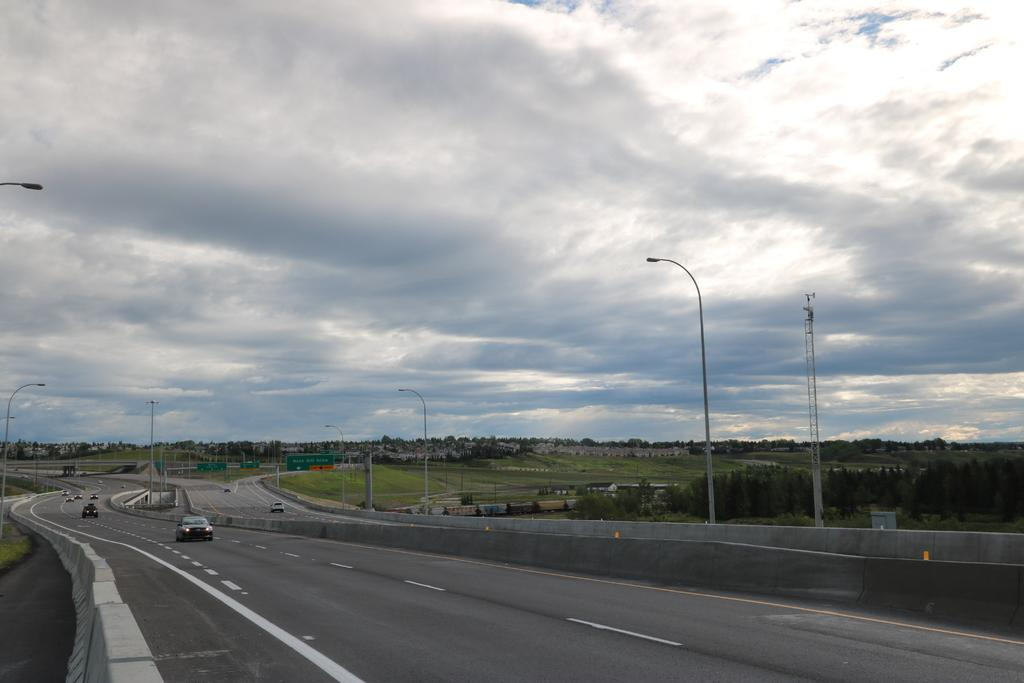What can be seen on the ground in the image? There are roads in the image. What is moving on the roads? There are vehicles on the roads. What structures are present alongside the roads? There are street light poles on the sides of the roads. What can be seen in the distance in the image? There are trees in the background of the image. What is visible above the trees in the image? The sky is visible in the background of the image, and clouds are present in the sky. How does the grip of the vehicle affect the credit score of the driver in the image? There is no information about the grip of the vehicle or the credit score of the driver in the image. The image only shows roads, vehicles, street light poles, trees, and the sky. 